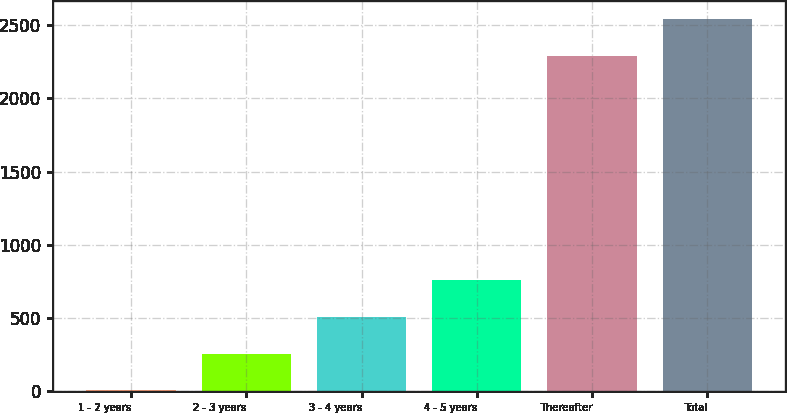Convert chart to OTSL. <chart><loc_0><loc_0><loc_500><loc_500><bar_chart><fcel>1 - 2 years<fcel>2 - 3 years<fcel>3 - 4 years<fcel>4 - 5 years<fcel>Thereafter<fcel>Total<nl><fcel>5<fcel>256.1<fcel>507.2<fcel>758.3<fcel>2291<fcel>2542.1<nl></chart> 